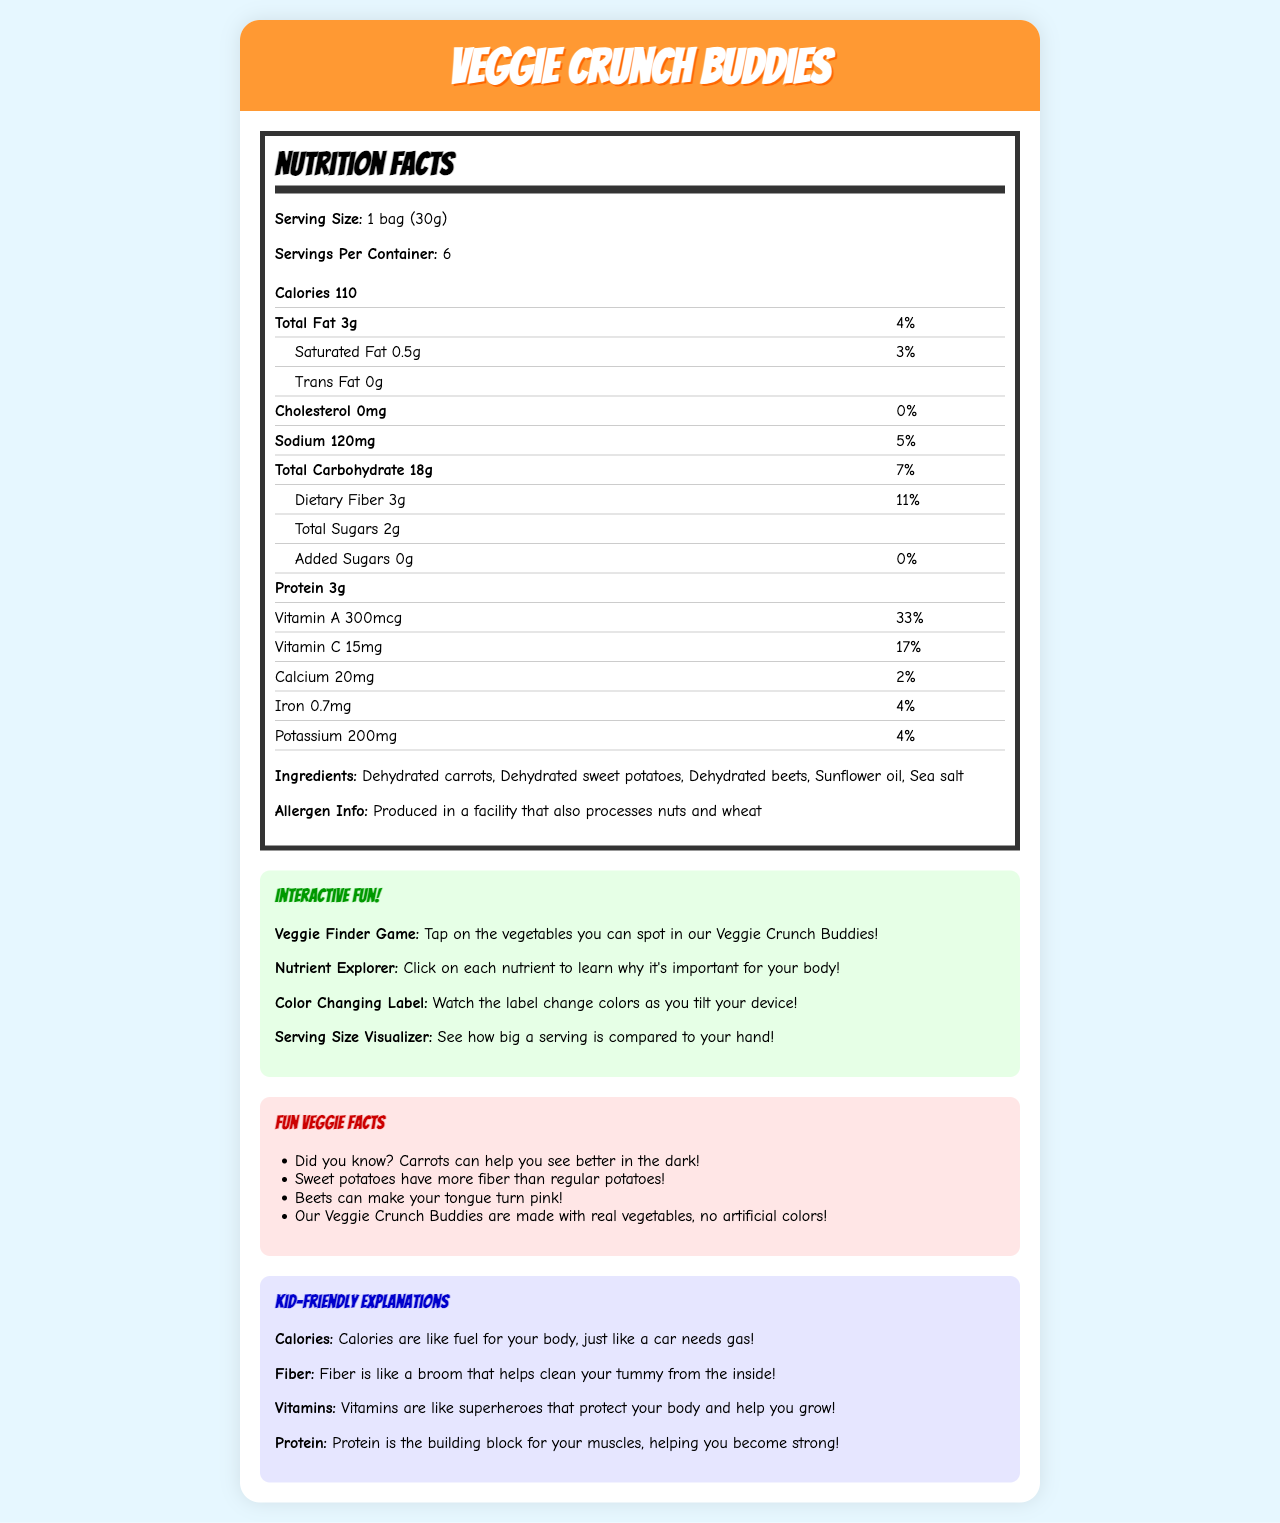when you eat a whole bag, how many calories would you consume? The label states that there are 110 calories per serving, and one bag is one serving.
Answer: 110 calories Is there any cholesterol in Veggie Crunch Buddies? The label shows that the amount of cholesterol is 0mg with a 0% daily value.
Answer: No What is the serving size for Veggie Crunch Buddies? The label clearly states that the serving size is "1 bag (30g)".
Answer: 1 bag (30g) How many grams of fiber are there in one serving? The label mentions that one serving contains 3 grams of dietary fiber.
Answer: 3 grams List any allergens present in the Veggie Crunch Buddies. The allergen information states that it is produced in a facility that also processes nuts and wheat.
Answer: Nuts and wheat Which vitamin has the highest percentage of daily value in Veggie Crunch Buddies? A. Vitamin A B. Vitamin C C. Calcium D. Iron Vitamin A has a 33% daily value, which is higher than the other vitamins and minerals listed.
Answer: A What ingredients are in Veggie Crunch Buddies? A. Dehydrated carrots B. Sugar C. Sunflower oil D. Sea salt E. All of the above The ingredients listed are dehydrated carrots, dehydrated sweet potatoes, dehydrated beets, sunflower oil, and sea salt.
Answer: E Is there any added sugar in Veggie Crunch Buddies? The label states that there are 0 grams of added sugars with a 0% daily value.
Answer: No Summarize the main idea of the document. The document covers the nutrition facts, ingredients, allergen information, interactive elements, and fun facts about Veggie Crunch Buddies, making the information engaging and accessible for children.
Answer: The document provides nutrition information for Veggie Crunch Buddies, a kid-friendly vegetable snack, highlighting its calories, fat, vitamins, and minerals per serving. It includes interactive elements for children, fun facts about the ingredients, and simple explanations of nutritional terms for kids. How much protein is there in a serving of Veggie Crunch Buddies? The nutrition label states that a serving contains 3 grams of protein.
Answer: 3 grams What is the percentage of daily value for sodium in one serving? The nutrition label indicates that one serving has 120mg of sodium, which is 5% of the daily value.
Answer: 5% Can the total number of bags in a container be determined? The document doesn't provide the total number of bags in a container; it only provides the serving size and servings per container.
Answer: No What is the purpose of vitamins in Veggie Crunch Buddies as explained in the document? The child-friendly explanation for vitamins is provided in a playful manner, stating that vitamins are like superheroes that protect the body and help it grow.
Answer: Vitamins are like superheroes that protect your body and help you grow! 